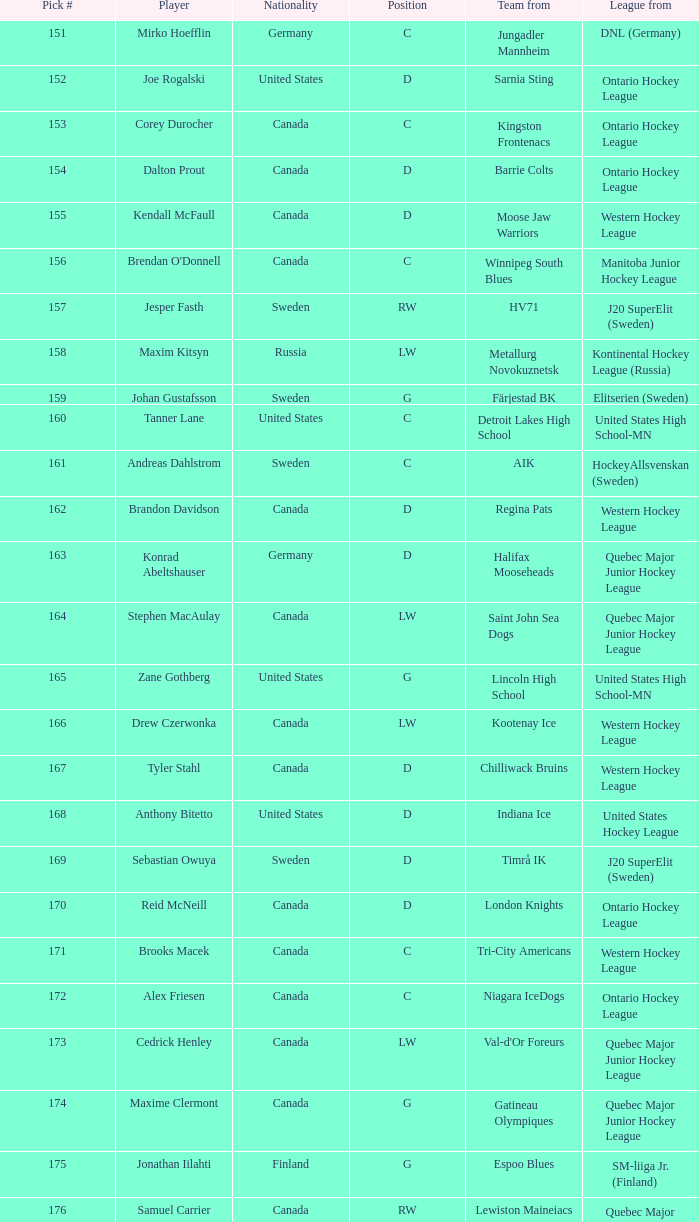What is the league that has the pick #160? United States High School-MN. 